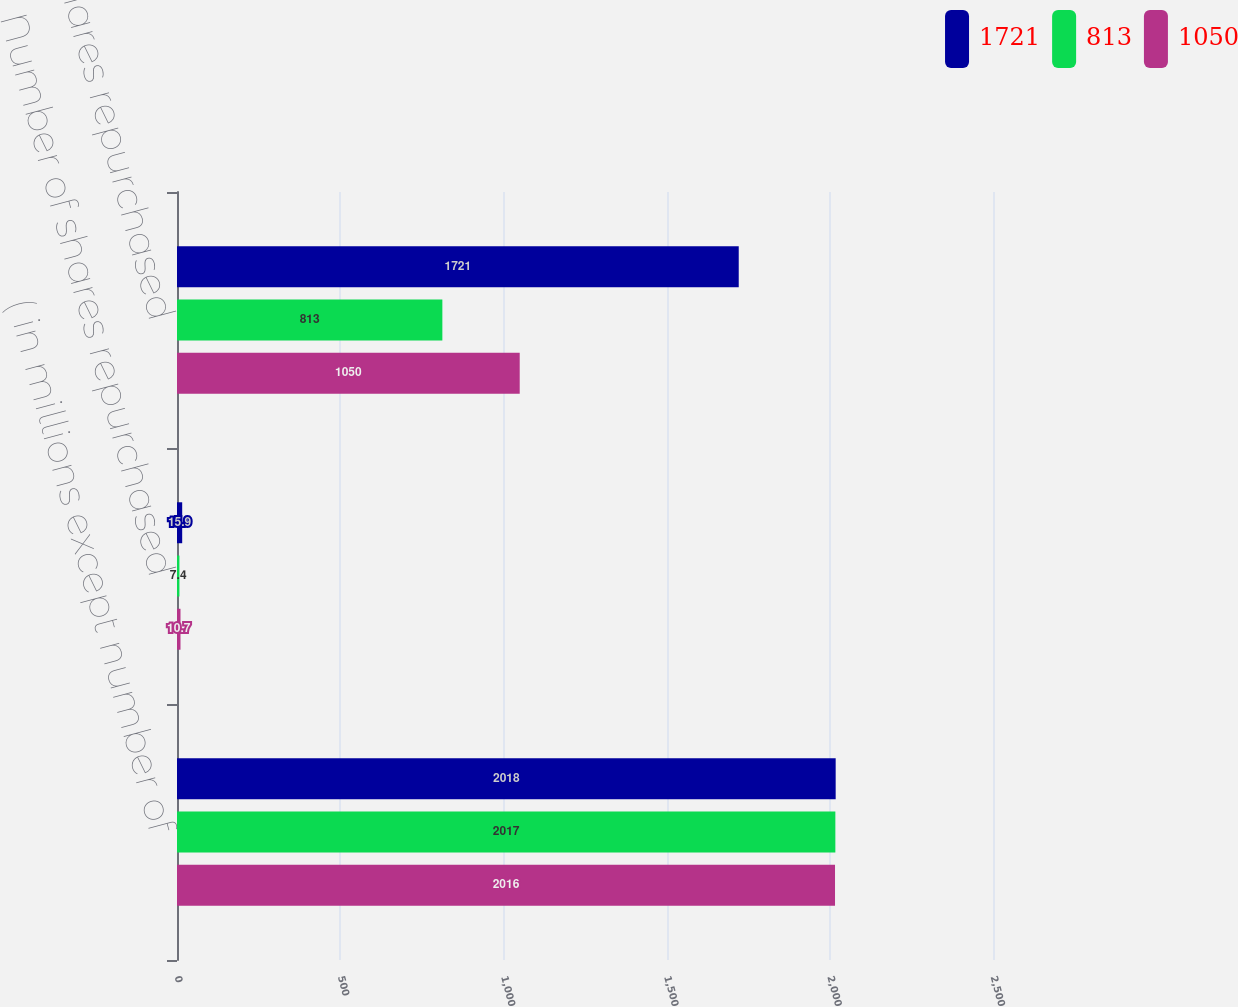Convert chart to OTSL. <chart><loc_0><loc_0><loc_500><loc_500><stacked_bar_chart><ecel><fcel>( in millions except number of<fcel>Number of shares repurchased<fcel>Cost of shares repurchased<nl><fcel>1721<fcel>2018<fcel>15.9<fcel>1721<nl><fcel>813<fcel>2017<fcel>7.4<fcel>813<nl><fcel>1050<fcel>2016<fcel>10.7<fcel>1050<nl></chart> 